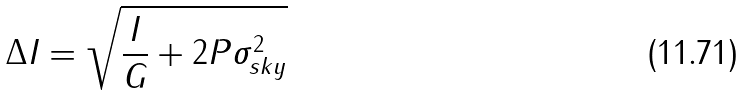Convert formula to latex. <formula><loc_0><loc_0><loc_500><loc_500>\Delta I = \sqrt { \frac { I } { G } + 2 P \sigma _ { s k y } ^ { 2 } }</formula> 